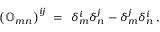<formula> <loc_0><loc_0><loc_500><loc_500>\left ( { \mathbb { O } } _ { m n } \right ) ^ { i j } \, = \, \delta _ { m } ^ { i } \delta _ { n } ^ { j } - \delta _ { m } ^ { j } \delta _ { n } ^ { i } \, ,</formula> 